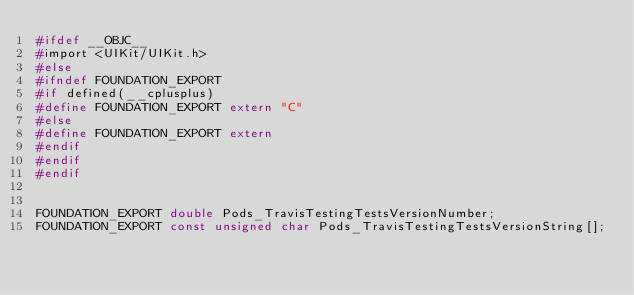<code> <loc_0><loc_0><loc_500><loc_500><_C_>#ifdef __OBJC__
#import <UIKit/UIKit.h>
#else
#ifndef FOUNDATION_EXPORT
#if defined(__cplusplus)
#define FOUNDATION_EXPORT extern "C"
#else
#define FOUNDATION_EXPORT extern
#endif
#endif
#endif


FOUNDATION_EXPORT double Pods_TravisTestingTestsVersionNumber;
FOUNDATION_EXPORT const unsigned char Pods_TravisTestingTestsVersionString[];

</code> 